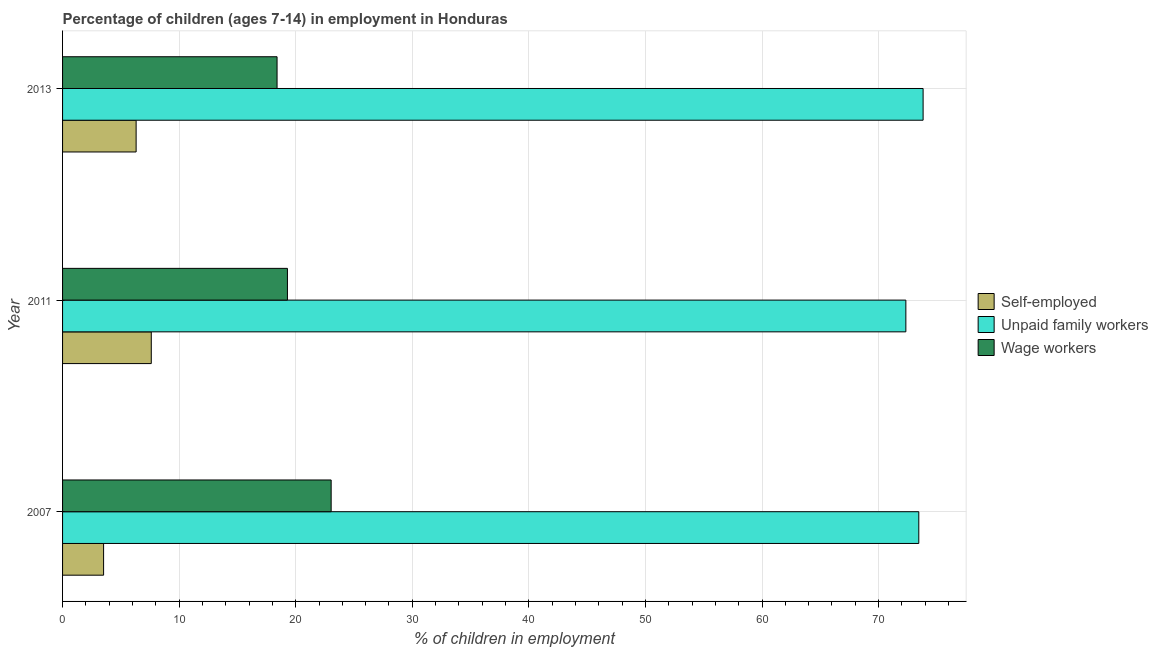How many different coloured bars are there?
Make the answer very short. 3. Are the number of bars on each tick of the Y-axis equal?
Your answer should be very brief. Yes. What is the label of the 2nd group of bars from the top?
Provide a succinct answer. 2011. In how many cases, is the number of bars for a given year not equal to the number of legend labels?
Your response must be concise. 0. What is the percentage of children employed as unpaid family workers in 2011?
Provide a succinct answer. 72.34. Across all years, what is the maximum percentage of children employed as wage workers?
Make the answer very short. 23.04. Across all years, what is the minimum percentage of children employed as wage workers?
Offer a terse response. 18.4. In which year was the percentage of children employed as wage workers maximum?
Your answer should be compact. 2007. In which year was the percentage of children employed as unpaid family workers minimum?
Provide a succinct answer. 2011. What is the total percentage of children employed as wage workers in the graph?
Give a very brief answer. 60.73. What is the difference between the percentage of self employed children in 2007 and that in 2013?
Provide a succinct answer. -2.79. What is the difference between the percentage of children employed as wage workers in 2007 and the percentage of children employed as unpaid family workers in 2013?
Give a very brief answer. -50.78. What is the average percentage of children employed as wage workers per year?
Offer a terse response. 20.24. In the year 2013, what is the difference between the percentage of self employed children and percentage of children employed as wage workers?
Ensure brevity in your answer.  -12.09. What is the ratio of the percentage of self employed children in 2011 to that in 2013?
Offer a very short reply. 1.21. Is the percentage of self employed children in 2011 less than that in 2013?
Your response must be concise. No. What is the difference between the highest and the second highest percentage of self employed children?
Offer a terse response. 1.3. What is the difference between the highest and the lowest percentage of children employed as wage workers?
Provide a succinct answer. 4.64. In how many years, is the percentage of children employed as unpaid family workers greater than the average percentage of children employed as unpaid family workers taken over all years?
Make the answer very short. 2. What does the 1st bar from the top in 2011 represents?
Offer a terse response. Wage workers. What does the 2nd bar from the bottom in 2007 represents?
Keep it short and to the point. Unpaid family workers. How many bars are there?
Offer a terse response. 9. Are all the bars in the graph horizontal?
Keep it short and to the point. Yes. Are the values on the major ticks of X-axis written in scientific E-notation?
Offer a very short reply. No. Does the graph contain grids?
Your answer should be compact. Yes. Where does the legend appear in the graph?
Offer a very short reply. Center right. What is the title of the graph?
Offer a very short reply. Percentage of children (ages 7-14) in employment in Honduras. What is the label or title of the X-axis?
Offer a very short reply. % of children in employment. What is the label or title of the Y-axis?
Provide a succinct answer. Year. What is the % of children in employment of Self-employed in 2007?
Offer a very short reply. 3.52. What is the % of children in employment in Unpaid family workers in 2007?
Provide a succinct answer. 73.45. What is the % of children in employment of Wage workers in 2007?
Your answer should be very brief. 23.04. What is the % of children in employment of Self-employed in 2011?
Give a very brief answer. 7.61. What is the % of children in employment of Unpaid family workers in 2011?
Your answer should be very brief. 72.34. What is the % of children in employment in Wage workers in 2011?
Provide a succinct answer. 19.29. What is the % of children in employment in Self-employed in 2013?
Your answer should be very brief. 6.31. What is the % of children in employment in Unpaid family workers in 2013?
Offer a very short reply. 73.82. Across all years, what is the maximum % of children in employment of Self-employed?
Keep it short and to the point. 7.61. Across all years, what is the maximum % of children in employment of Unpaid family workers?
Your response must be concise. 73.82. Across all years, what is the maximum % of children in employment in Wage workers?
Keep it short and to the point. 23.04. Across all years, what is the minimum % of children in employment in Self-employed?
Make the answer very short. 3.52. Across all years, what is the minimum % of children in employment in Unpaid family workers?
Keep it short and to the point. 72.34. What is the total % of children in employment of Self-employed in the graph?
Your response must be concise. 17.44. What is the total % of children in employment of Unpaid family workers in the graph?
Provide a short and direct response. 219.61. What is the total % of children in employment in Wage workers in the graph?
Offer a terse response. 60.73. What is the difference between the % of children in employment of Self-employed in 2007 and that in 2011?
Make the answer very short. -4.09. What is the difference between the % of children in employment of Unpaid family workers in 2007 and that in 2011?
Give a very brief answer. 1.11. What is the difference between the % of children in employment in Wage workers in 2007 and that in 2011?
Ensure brevity in your answer.  3.75. What is the difference between the % of children in employment in Self-employed in 2007 and that in 2013?
Your answer should be compact. -2.79. What is the difference between the % of children in employment of Unpaid family workers in 2007 and that in 2013?
Ensure brevity in your answer.  -0.37. What is the difference between the % of children in employment of Wage workers in 2007 and that in 2013?
Give a very brief answer. 4.64. What is the difference between the % of children in employment of Self-employed in 2011 and that in 2013?
Provide a short and direct response. 1.3. What is the difference between the % of children in employment of Unpaid family workers in 2011 and that in 2013?
Provide a succinct answer. -1.48. What is the difference between the % of children in employment in Wage workers in 2011 and that in 2013?
Provide a short and direct response. 0.89. What is the difference between the % of children in employment in Self-employed in 2007 and the % of children in employment in Unpaid family workers in 2011?
Give a very brief answer. -68.82. What is the difference between the % of children in employment in Self-employed in 2007 and the % of children in employment in Wage workers in 2011?
Give a very brief answer. -15.77. What is the difference between the % of children in employment in Unpaid family workers in 2007 and the % of children in employment in Wage workers in 2011?
Ensure brevity in your answer.  54.16. What is the difference between the % of children in employment in Self-employed in 2007 and the % of children in employment in Unpaid family workers in 2013?
Offer a terse response. -70.3. What is the difference between the % of children in employment in Self-employed in 2007 and the % of children in employment in Wage workers in 2013?
Your answer should be compact. -14.88. What is the difference between the % of children in employment of Unpaid family workers in 2007 and the % of children in employment of Wage workers in 2013?
Give a very brief answer. 55.05. What is the difference between the % of children in employment in Self-employed in 2011 and the % of children in employment in Unpaid family workers in 2013?
Your answer should be very brief. -66.21. What is the difference between the % of children in employment in Self-employed in 2011 and the % of children in employment in Wage workers in 2013?
Ensure brevity in your answer.  -10.79. What is the difference between the % of children in employment in Unpaid family workers in 2011 and the % of children in employment in Wage workers in 2013?
Your answer should be compact. 53.94. What is the average % of children in employment of Self-employed per year?
Your response must be concise. 5.81. What is the average % of children in employment in Unpaid family workers per year?
Ensure brevity in your answer.  73.2. What is the average % of children in employment of Wage workers per year?
Offer a very short reply. 20.24. In the year 2007, what is the difference between the % of children in employment in Self-employed and % of children in employment in Unpaid family workers?
Your answer should be compact. -69.93. In the year 2007, what is the difference between the % of children in employment in Self-employed and % of children in employment in Wage workers?
Make the answer very short. -19.52. In the year 2007, what is the difference between the % of children in employment in Unpaid family workers and % of children in employment in Wage workers?
Make the answer very short. 50.41. In the year 2011, what is the difference between the % of children in employment in Self-employed and % of children in employment in Unpaid family workers?
Provide a short and direct response. -64.73. In the year 2011, what is the difference between the % of children in employment in Self-employed and % of children in employment in Wage workers?
Provide a succinct answer. -11.68. In the year 2011, what is the difference between the % of children in employment of Unpaid family workers and % of children in employment of Wage workers?
Offer a very short reply. 53.05. In the year 2013, what is the difference between the % of children in employment in Self-employed and % of children in employment in Unpaid family workers?
Offer a terse response. -67.51. In the year 2013, what is the difference between the % of children in employment in Self-employed and % of children in employment in Wage workers?
Provide a short and direct response. -12.09. In the year 2013, what is the difference between the % of children in employment in Unpaid family workers and % of children in employment in Wage workers?
Offer a terse response. 55.42. What is the ratio of the % of children in employment in Self-employed in 2007 to that in 2011?
Ensure brevity in your answer.  0.46. What is the ratio of the % of children in employment of Unpaid family workers in 2007 to that in 2011?
Provide a succinct answer. 1.02. What is the ratio of the % of children in employment in Wage workers in 2007 to that in 2011?
Make the answer very short. 1.19. What is the ratio of the % of children in employment of Self-employed in 2007 to that in 2013?
Keep it short and to the point. 0.56. What is the ratio of the % of children in employment of Wage workers in 2007 to that in 2013?
Offer a terse response. 1.25. What is the ratio of the % of children in employment in Self-employed in 2011 to that in 2013?
Your response must be concise. 1.21. What is the ratio of the % of children in employment in Unpaid family workers in 2011 to that in 2013?
Your answer should be very brief. 0.98. What is the ratio of the % of children in employment in Wage workers in 2011 to that in 2013?
Provide a short and direct response. 1.05. What is the difference between the highest and the second highest % of children in employment of Unpaid family workers?
Your answer should be very brief. 0.37. What is the difference between the highest and the second highest % of children in employment of Wage workers?
Provide a succinct answer. 3.75. What is the difference between the highest and the lowest % of children in employment of Self-employed?
Give a very brief answer. 4.09. What is the difference between the highest and the lowest % of children in employment of Unpaid family workers?
Provide a short and direct response. 1.48. What is the difference between the highest and the lowest % of children in employment in Wage workers?
Ensure brevity in your answer.  4.64. 